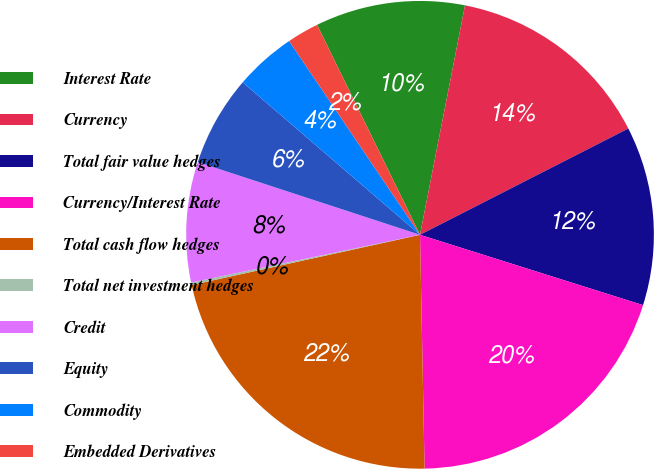<chart> <loc_0><loc_0><loc_500><loc_500><pie_chart><fcel>Interest Rate<fcel>Currency<fcel>Total fair value hedges<fcel>Currency/Interest Rate<fcel>Total cash flow hedges<fcel>Total net investment hedges<fcel>Credit<fcel>Equity<fcel>Commodity<fcel>Embedded Derivatives<nl><fcel>10.34%<fcel>14.41%<fcel>12.37%<fcel>19.83%<fcel>21.87%<fcel>0.17%<fcel>8.31%<fcel>6.27%<fcel>4.24%<fcel>2.2%<nl></chart> 